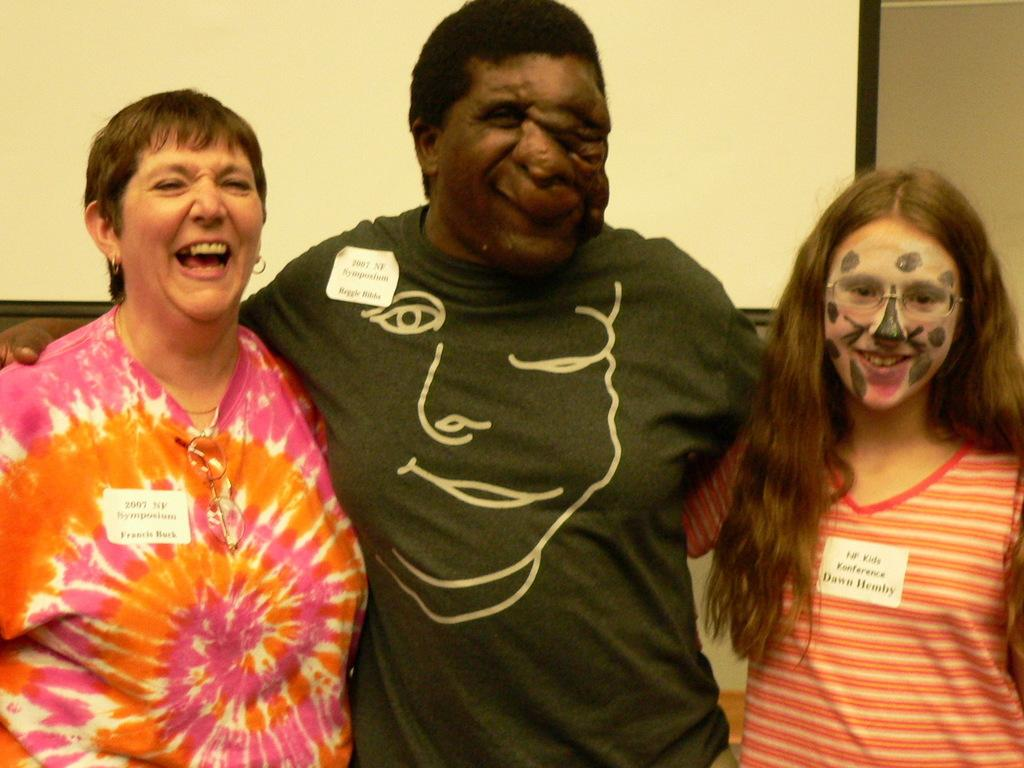How many people are in the image? There are three persons in the center of the image. What are the people doing in the image? The persons are smiling in the image. What are the people wearing in the image? The persons are wearing t-shirts in the image. What is the position of the people in the image? The persons are standing in the image. What can be seen in the background of the image? There is a wall in the background of the image. What type of tin can be seen in the image? There is no tin present in the image. Is there any grass visible in the image? There is no grass visible in the image. 